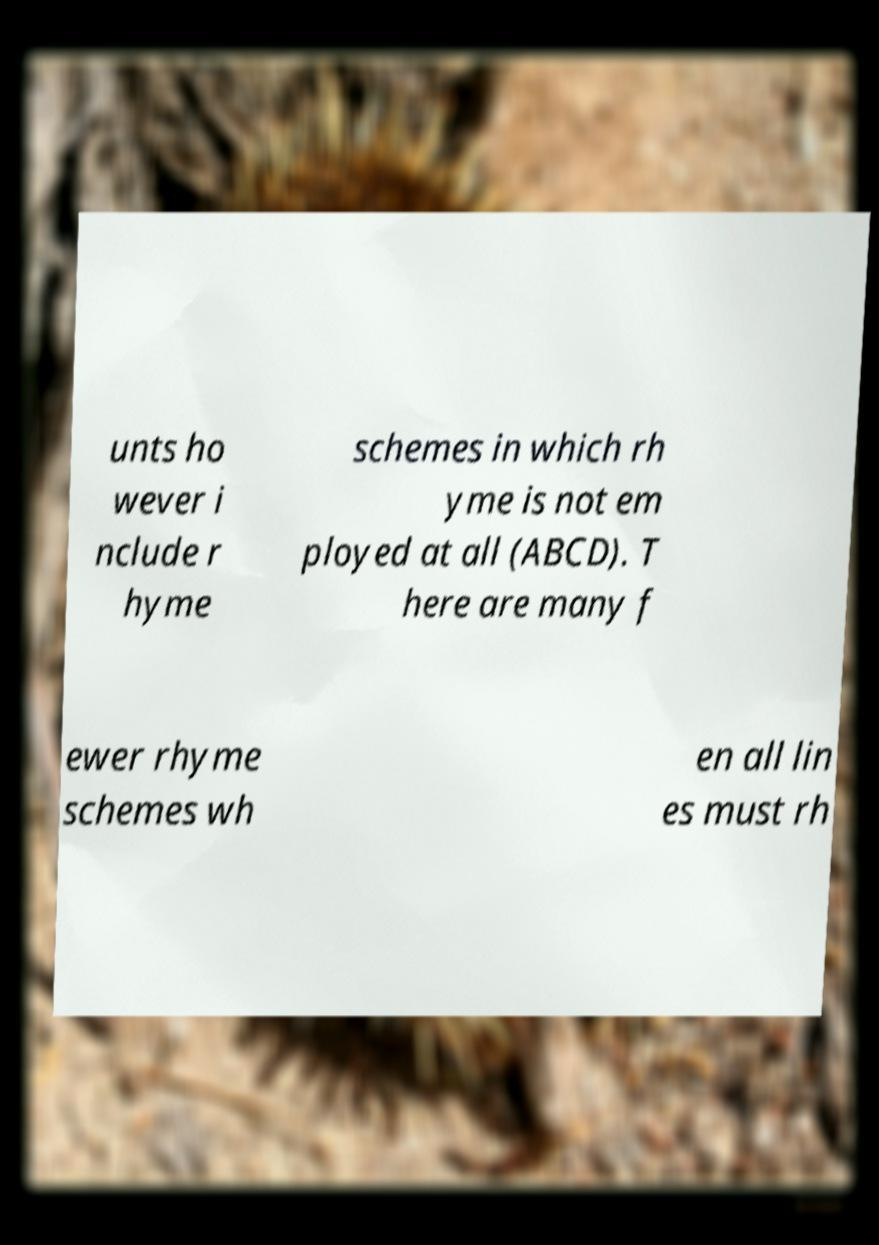There's text embedded in this image that I need extracted. Can you transcribe it verbatim? unts ho wever i nclude r hyme schemes in which rh yme is not em ployed at all (ABCD). T here are many f ewer rhyme schemes wh en all lin es must rh 